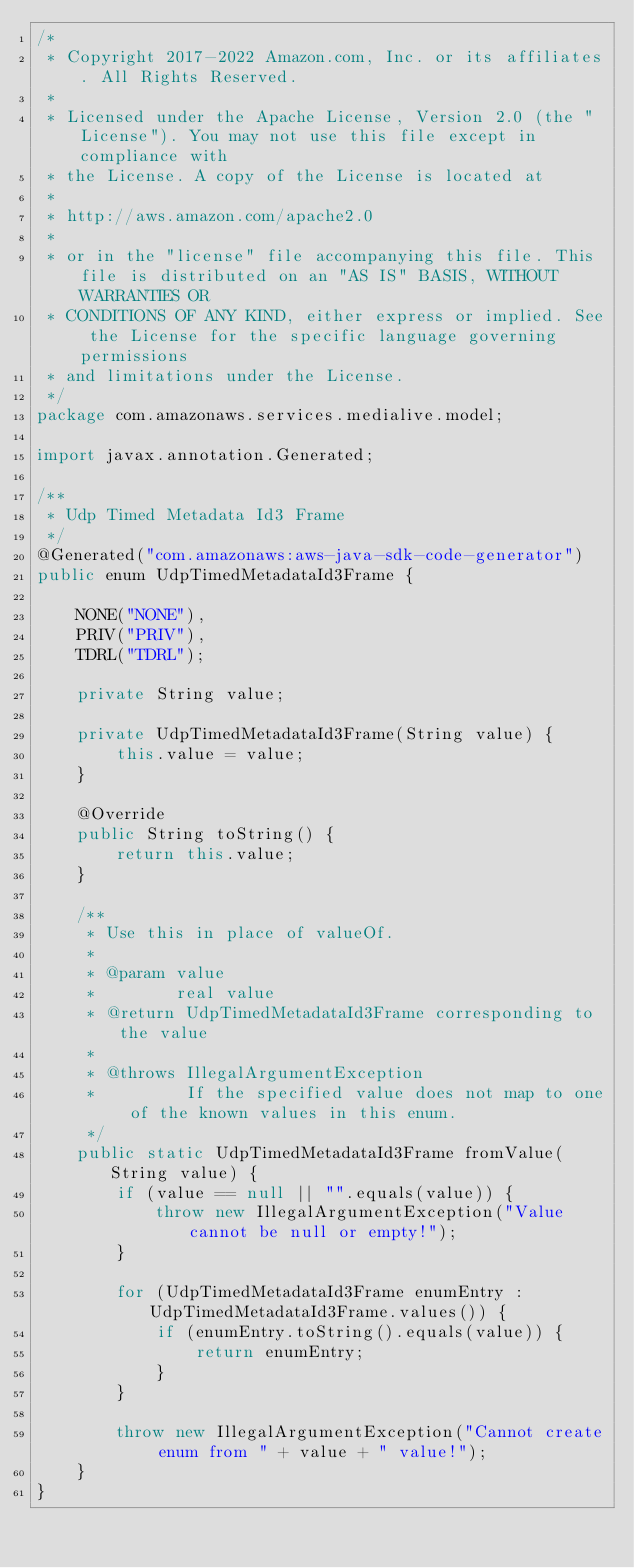<code> <loc_0><loc_0><loc_500><loc_500><_Java_>/*
 * Copyright 2017-2022 Amazon.com, Inc. or its affiliates. All Rights Reserved.
 * 
 * Licensed under the Apache License, Version 2.0 (the "License"). You may not use this file except in compliance with
 * the License. A copy of the License is located at
 * 
 * http://aws.amazon.com/apache2.0
 * 
 * or in the "license" file accompanying this file. This file is distributed on an "AS IS" BASIS, WITHOUT WARRANTIES OR
 * CONDITIONS OF ANY KIND, either express or implied. See the License for the specific language governing permissions
 * and limitations under the License.
 */
package com.amazonaws.services.medialive.model;

import javax.annotation.Generated;

/**
 * Udp Timed Metadata Id3 Frame
 */
@Generated("com.amazonaws:aws-java-sdk-code-generator")
public enum UdpTimedMetadataId3Frame {

    NONE("NONE"),
    PRIV("PRIV"),
    TDRL("TDRL");

    private String value;

    private UdpTimedMetadataId3Frame(String value) {
        this.value = value;
    }

    @Override
    public String toString() {
        return this.value;
    }

    /**
     * Use this in place of valueOf.
     *
     * @param value
     *        real value
     * @return UdpTimedMetadataId3Frame corresponding to the value
     *
     * @throws IllegalArgumentException
     *         If the specified value does not map to one of the known values in this enum.
     */
    public static UdpTimedMetadataId3Frame fromValue(String value) {
        if (value == null || "".equals(value)) {
            throw new IllegalArgumentException("Value cannot be null or empty!");
        }

        for (UdpTimedMetadataId3Frame enumEntry : UdpTimedMetadataId3Frame.values()) {
            if (enumEntry.toString().equals(value)) {
                return enumEntry;
            }
        }

        throw new IllegalArgumentException("Cannot create enum from " + value + " value!");
    }
}
</code> 